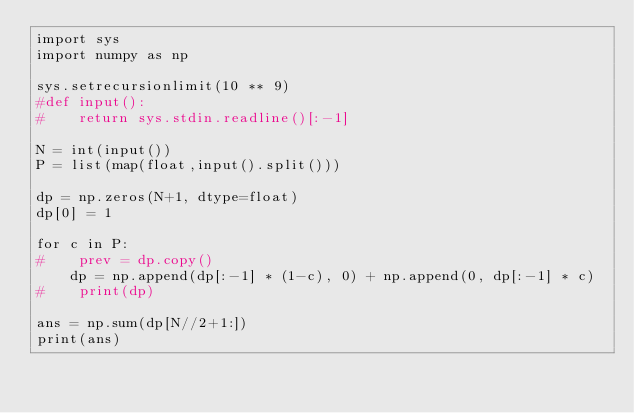<code> <loc_0><loc_0><loc_500><loc_500><_Python_>import sys
import numpy as np

sys.setrecursionlimit(10 ** 9)
#def input():
#    return sys.stdin.readline()[:-1]

N = int(input())
P = list(map(float,input().split()))

dp = np.zeros(N+1, dtype=float)
dp[0] = 1

for c in P:
#    prev = dp.copy()
    dp = np.append(dp[:-1] * (1-c), 0) + np.append(0, dp[:-1] * c)
#    print(dp)

ans = np.sum(dp[N//2+1:])
print(ans)
</code> 